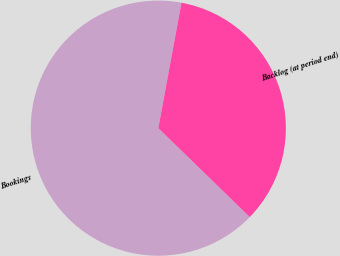Convert chart to OTSL. <chart><loc_0><loc_0><loc_500><loc_500><pie_chart><fcel>Bookings<fcel>Backlog (at period end)<nl><fcel>65.63%<fcel>34.37%<nl></chart> 